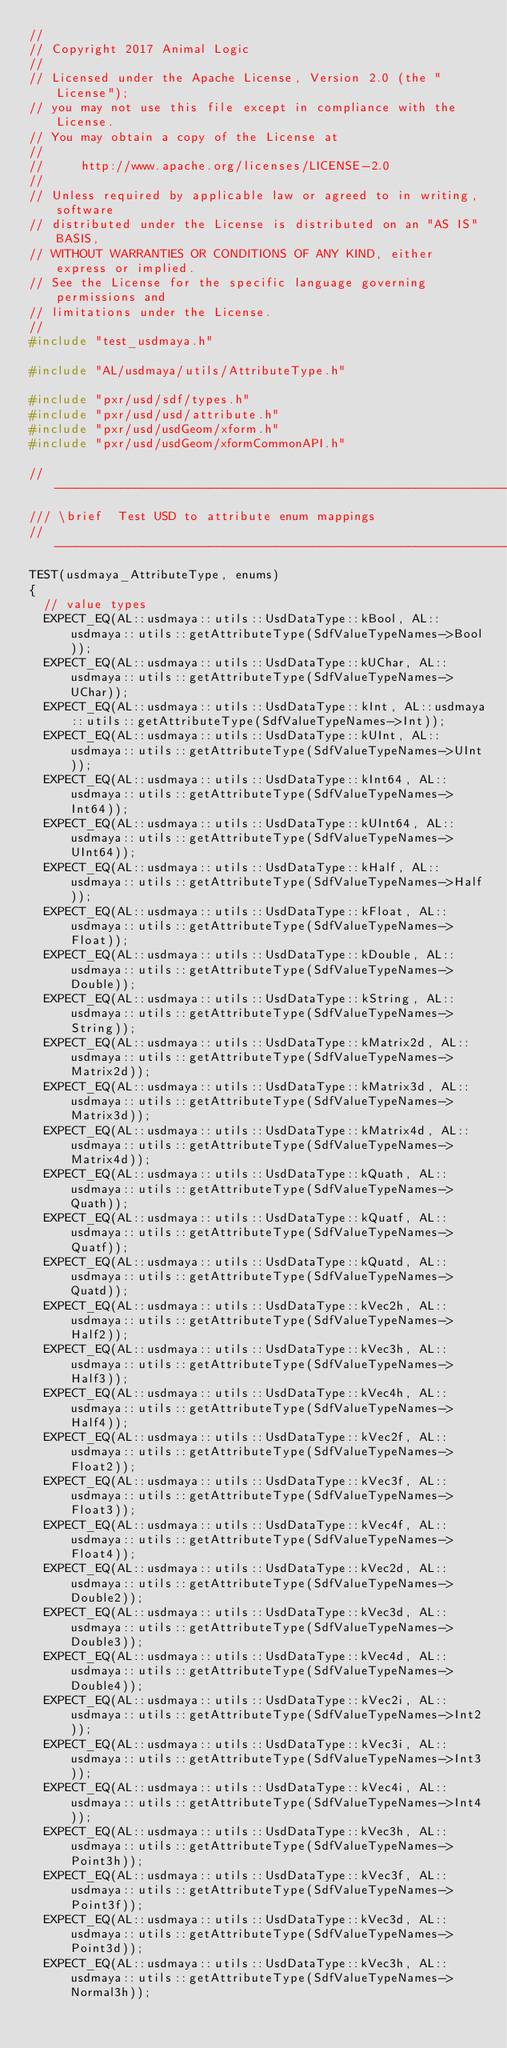<code> <loc_0><loc_0><loc_500><loc_500><_C++_>//
// Copyright 2017 Animal Logic
//
// Licensed under the Apache License, Version 2.0 (the "License");
// you may not use this file except in compliance with the License.
// You may obtain a copy of the License at
//
//     http://www.apache.org/licenses/LICENSE-2.0
//
// Unless required by applicable law or agreed to in writing, software
// distributed under the License is distributed on an "AS IS" BASIS,
// WITHOUT WARRANTIES OR CONDITIONS OF ANY KIND, either express or implied.
// See the License for the specific language governing permissions and
// limitations under the License.
//
#include "test_usdmaya.h"

#include "AL/usdmaya/utils/AttributeType.h"

#include "pxr/usd/sdf/types.h"
#include "pxr/usd/usd/attribute.h"
#include "pxr/usd/usdGeom/xform.h"
#include "pxr/usd/usdGeom/xformCommonAPI.h"

//----------------------------------------------------------------------------------------------------------------------
/// \brief  Test USD to attribute enum mappings
//----------------------------------------------------------------------------------------------------------------------
TEST(usdmaya_AttributeType, enums)
{
  // value types
  EXPECT_EQ(AL::usdmaya::utils::UsdDataType::kBool, AL::usdmaya::utils::getAttributeType(SdfValueTypeNames->Bool));
  EXPECT_EQ(AL::usdmaya::utils::UsdDataType::kUChar, AL::usdmaya::utils::getAttributeType(SdfValueTypeNames->UChar));
  EXPECT_EQ(AL::usdmaya::utils::UsdDataType::kInt, AL::usdmaya::utils::getAttributeType(SdfValueTypeNames->Int));
  EXPECT_EQ(AL::usdmaya::utils::UsdDataType::kUInt, AL::usdmaya::utils::getAttributeType(SdfValueTypeNames->UInt));
  EXPECT_EQ(AL::usdmaya::utils::UsdDataType::kInt64, AL::usdmaya::utils::getAttributeType(SdfValueTypeNames->Int64));
  EXPECT_EQ(AL::usdmaya::utils::UsdDataType::kUInt64, AL::usdmaya::utils::getAttributeType(SdfValueTypeNames->UInt64));
  EXPECT_EQ(AL::usdmaya::utils::UsdDataType::kHalf, AL::usdmaya::utils::getAttributeType(SdfValueTypeNames->Half));
  EXPECT_EQ(AL::usdmaya::utils::UsdDataType::kFloat, AL::usdmaya::utils::getAttributeType(SdfValueTypeNames->Float));
  EXPECT_EQ(AL::usdmaya::utils::UsdDataType::kDouble, AL::usdmaya::utils::getAttributeType(SdfValueTypeNames->Double));
  EXPECT_EQ(AL::usdmaya::utils::UsdDataType::kString, AL::usdmaya::utils::getAttributeType(SdfValueTypeNames->String));
  EXPECT_EQ(AL::usdmaya::utils::UsdDataType::kMatrix2d, AL::usdmaya::utils::getAttributeType(SdfValueTypeNames->Matrix2d));
  EXPECT_EQ(AL::usdmaya::utils::UsdDataType::kMatrix3d, AL::usdmaya::utils::getAttributeType(SdfValueTypeNames->Matrix3d));
  EXPECT_EQ(AL::usdmaya::utils::UsdDataType::kMatrix4d, AL::usdmaya::utils::getAttributeType(SdfValueTypeNames->Matrix4d));
  EXPECT_EQ(AL::usdmaya::utils::UsdDataType::kQuath, AL::usdmaya::utils::getAttributeType(SdfValueTypeNames->Quath));
  EXPECT_EQ(AL::usdmaya::utils::UsdDataType::kQuatf, AL::usdmaya::utils::getAttributeType(SdfValueTypeNames->Quatf));
  EXPECT_EQ(AL::usdmaya::utils::UsdDataType::kQuatd, AL::usdmaya::utils::getAttributeType(SdfValueTypeNames->Quatd));
  EXPECT_EQ(AL::usdmaya::utils::UsdDataType::kVec2h, AL::usdmaya::utils::getAttributeType(SdfValueTypeNames->Half2));
  EXPECT_EQ(AL::usdmaya::utils::UsdDataType::kVec3h, AL::usdmaya::utils::getAttributeType(SdfValueTypeNames->Half3));
  EXPECT_EQ(AL::usdmaya::utils::UsdDataType::kVec4h, AL::usdmaya::utils::getAttributeType(SdfValueTypeNames->Half4));
  EXPECT_EQ(AL::usdmaya::utils::UsdDataType::kVec2f, AL::usdmaya::utils::getAttributeType(SdfValueTypeNames->Float2));
  EXPECT_EQ(AL::usdmaya::utils::UsdDataType::kVec3f, AL::usdmaya::utils::getAttributeType(SdfValueTypeNames->Float3));
  EXPECT_EQ(AL::usdmaya::utils::UsdDataType::kVec4f, AL::usdmaya::utils::getAttributeType(SdfValueTypeNames->Float4));
  EXPECT_EQ(AL::usdmaya::utils::UsdDataType::kVec2d, AL::usdmaya::utils::getAttributeType(SdfValueTypeNames->Double2));
  EXPECT_EQ(AL::usdmaya::utils::UsdDataType::kVec3d, AL::usdmaya::utils::getAttributeType(SdfValueTypeNames->Double3));
  EXPECT_EQ(AL::usdmaya::utils::UsdDataType::kVec4d, AL::usdmaya::utils::getAttributeType(SdfValueTypeNames->Double4));
  EXPECT_EQ(AL::usdmaya::utils::UsdDataType::kVec2i, AL::usdmaya::utils::getAttributeType(SdfValueTypeNames->Int2));
  EXPECT_EQ(AL::usdmaya::utils::UsdDataType::kVec3i, AL::usdmaya::utils::getAttributeType(SdfValueTypeNames->Int3));
  EXPECT_EQ(AL::usdmaya::utils::UsdDataType::kVec4i, AL::usdmaya::utils::getAttributeType(SdfValueTypeNames->Int4));
  EXPECT_EQ(AL::usdmaya::utils::UsdDataType::kVec3h, AL::usdmaya::utils::getAttributeType(SdfValueTypeNames->Point3h));
  EXPECT_EQ(AL::usdmaya::utils::UsdDataType::kVec3f, AL::usdmaya::utils::getAttributeType(SdfValueTypeNames->Point3f));
  EXPECT_EQ(AL::usdmaya::utils::UsdDataType::kVec3d, AL::usdmaya::utils::getAttributeType(SdfValueTypeNames->Point3d));
  EXPECT_EQ(AL::usdmaya::utils::UsdDataType::kVec3h, AL::usdmaya::utils::getAttributeType(SdfValueTypeNames->Normal3h));</code> 